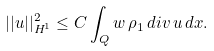<formula> <loc_0><loc_0><loc_500><loc_500>| | u | | _ { H ^ { 1 } } ^ { 2 } \leq C \int _ { Q } w \, \rho _ { 1 } \, d i v \, u \, d x .</formula> 